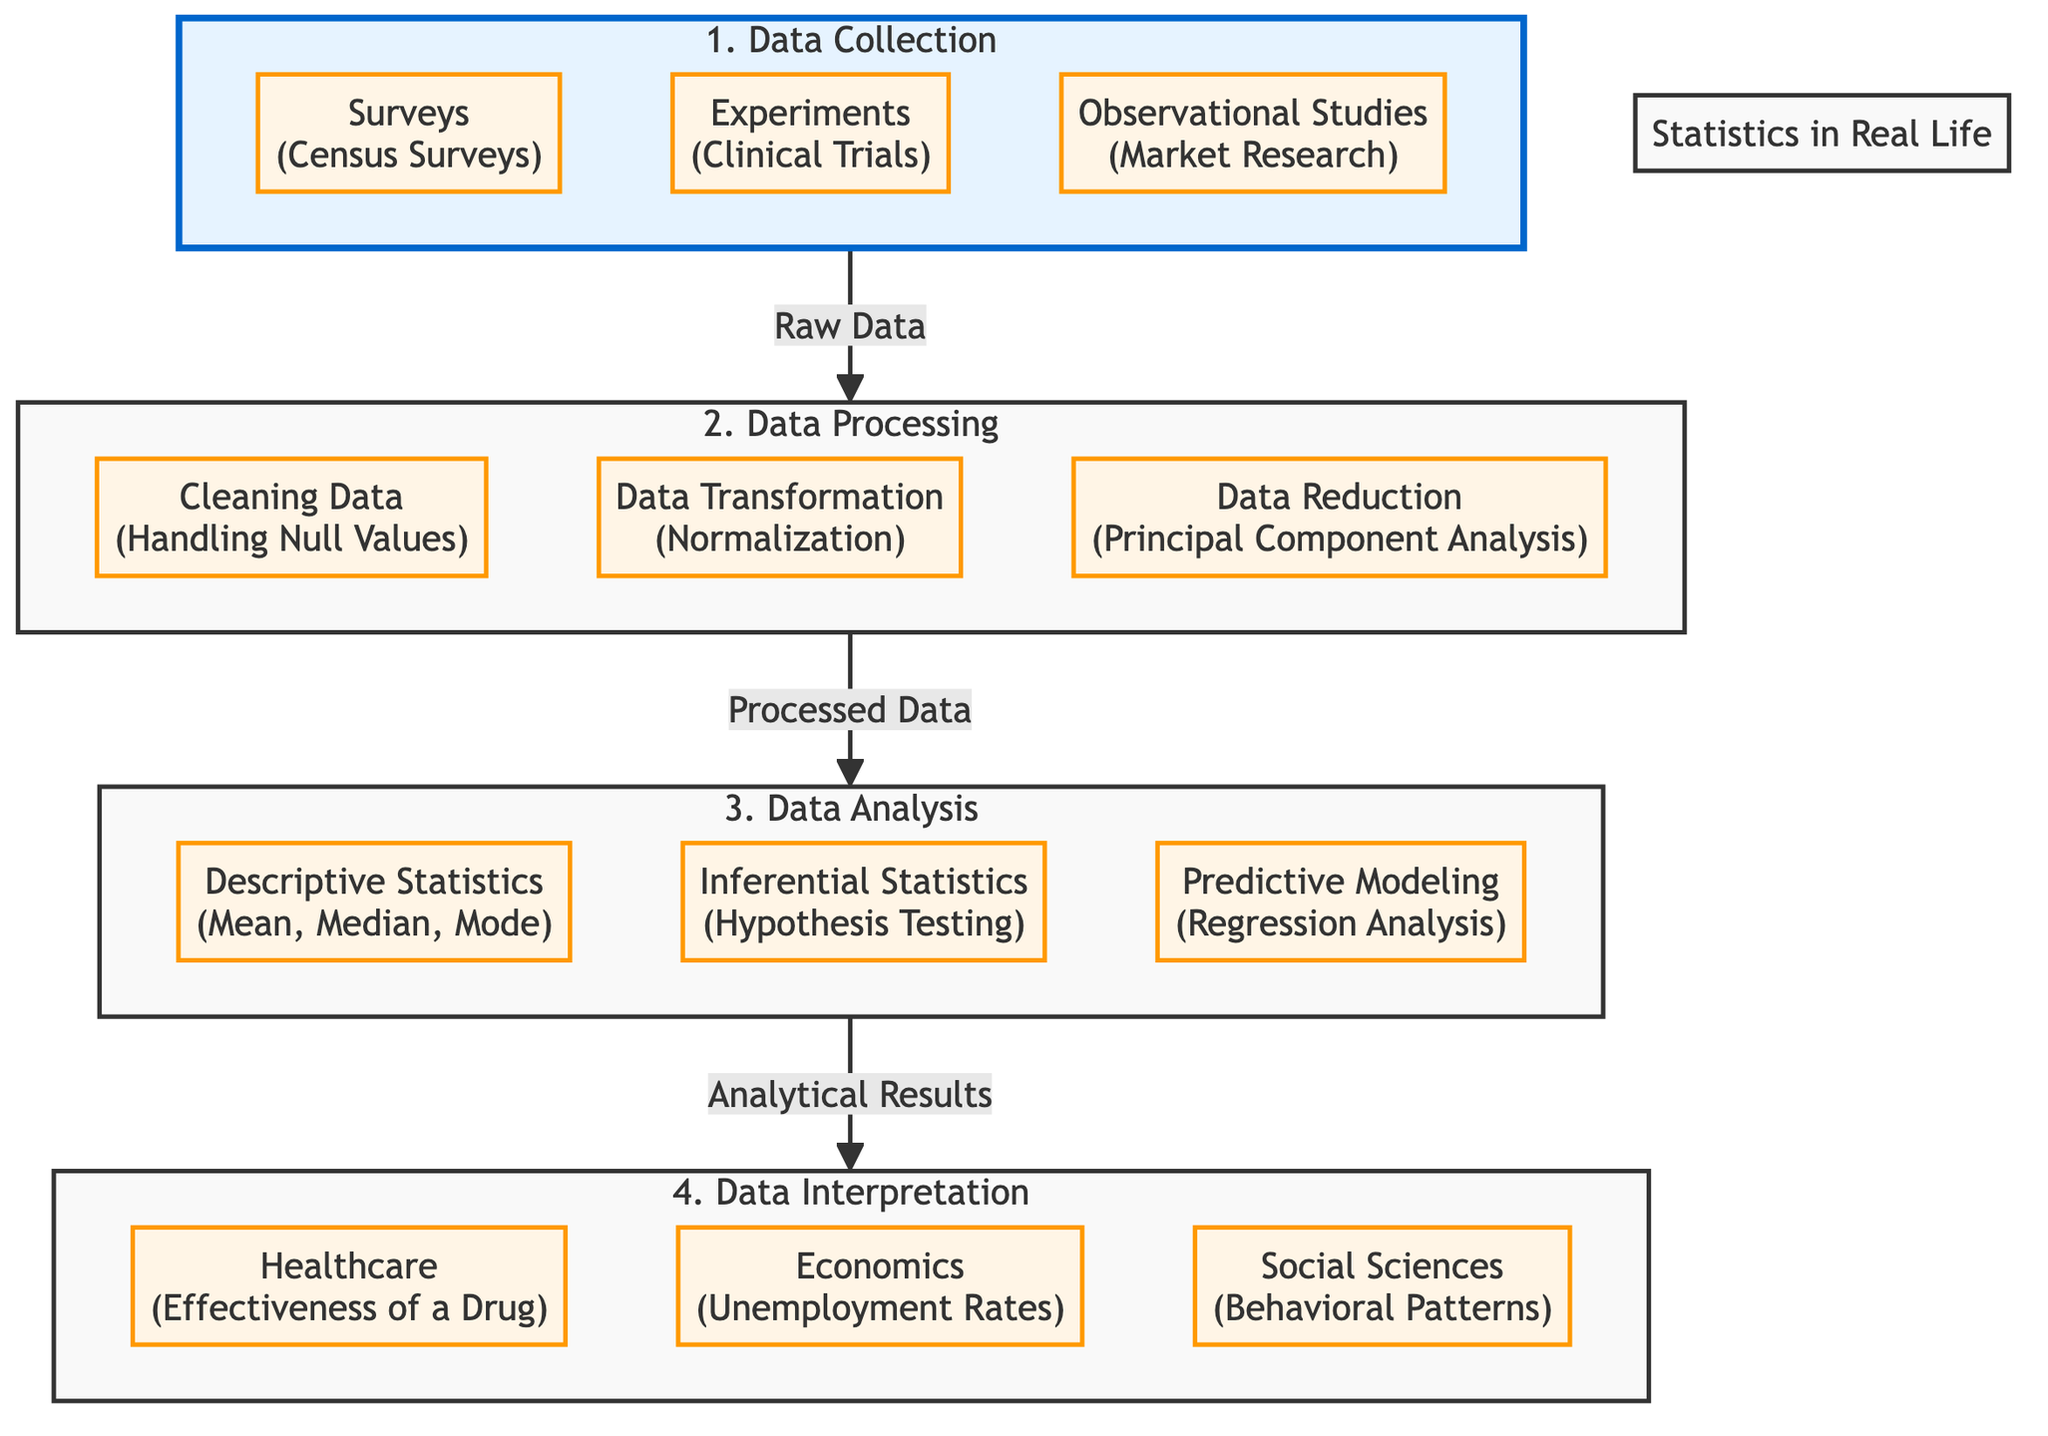What are the three stages of the diagram? The diagram includes four stages listed in the subgraphs: Data Collection, Data Processing, Data Analysis, and Data Interpretation. The question asks for three, so we can focus on the first three: Data Collection, Data Processing, and Data Analysis.
Answer: Data Collection, Data Processing, Data Analysis How many elements are in the Data Collection stage? The Data Collection stage has three elements listed: Surveys, Experiments, and Observational Studies. Therefore, the total number of elements in this stage is three.
Answer: 3 What type of statistics involves hypothesis testing? In the Data Analysis phase, Inferential Statistics is the type that includes hypothesis testing as one of its key methods. This is specified within that specific section.
Answer: Inferential Statistics Which type of data processing handles null values? The element that addresses null values in the Data Processing stage is Cleaning Data. This specific aspect falls under the responsibilities of the data cleaning process.
Answer: Cleaning Data What follows Data Processing in the flow of the diagram? After the Data Processing stage, the flow moves to the Data Analysis stage. The arrows indicate the progression from processed data to subsequent analysis.
Answer: Data Analysis Which field is associated with the effectiveness of a drug? In the Data Interpretation stage, Healthcare is linked to evaluating the effectiveness of a drug. This is explicitly stated in the corresponding box under interpretation.
Answer: Healthcare How many types of descriptive statistics are mentioned in the diagram? The diagram lists three types of descriptive statistics: Mean, Median, and Mode. These represent the key methods of summarizing or describing data.
Answer: 3 What is the final stage of the statistical analysis flow? The final stage of the flow, as indicated in the diagram, is Data Interpretation. This is the last step where analytical results are interpreted across various fields.
Answer: Data Interpretation 